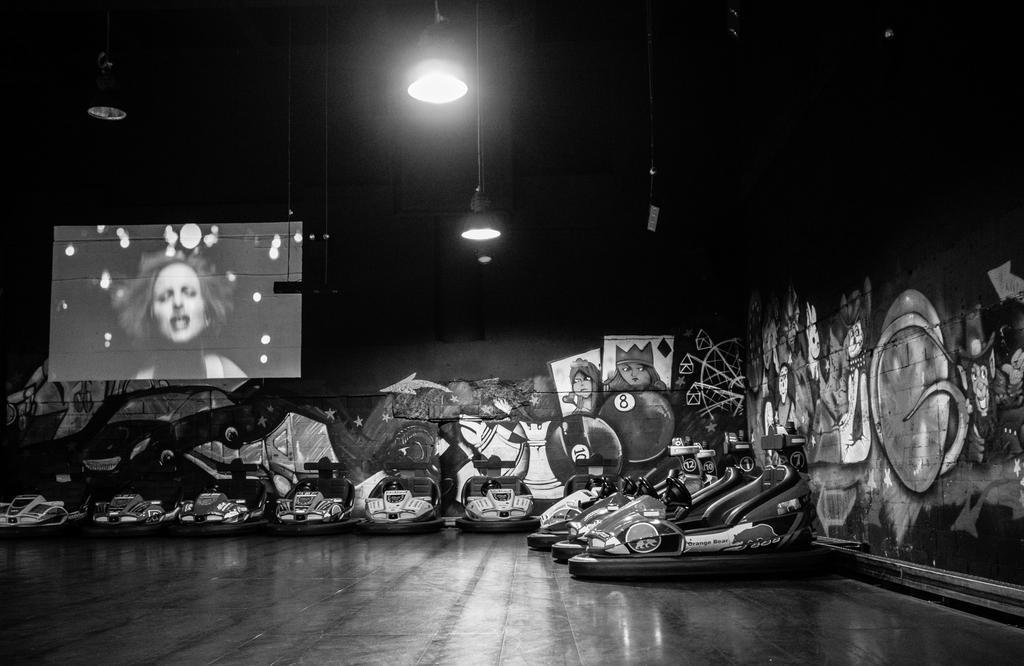Can you describe this image briefly? This is a black and white picture. I can see vehicles, lights, screen, and in the background there are paintings on the walls. 